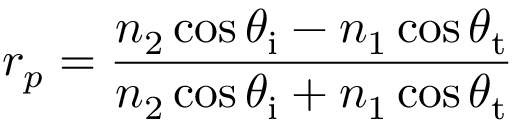Convert formula to latex. <formula><loc_0><loc_0><loc_500><loc_500>r _ { p } = { \frac { n _ { 2 } \cos \theta _ { i } - n _ { 1 } \cos \theta _ { t } } { n _ { 2 } \cos \theta _ { i } + n _ { 1 } \cos \theta _ { t } } }</formula> 